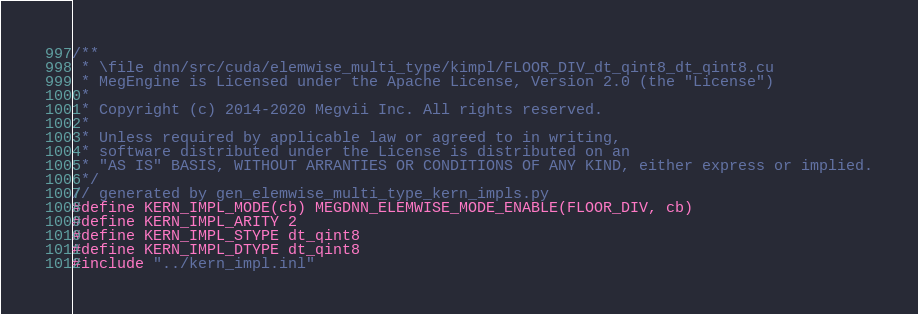Convert code to text. <code><loc_0><loc_0><loc_500><loc_500><_Cuda_>/**
 * \file dnn/src/cuda/elemwise_multi_type/kimpl/FLOOR_DIV_dt_qint8_dt_qint8.cu
 * MegEngine is Licensed under the Apache License, Version 2.0 (the "License")
 *
 * Copyright (c) 2014-2020 Megvii Inc. All rights reserved.
 *
 * Unless required by applicable law or agreed to in writing,
 * software distributed under the License is distributed on an
 * "AS IS" BASIS, WITHOUT ARRANTIES OR CONDITIONS OF ANY KIND, either express or implied.
 */
// generated by gen_elemwise_multi_type_kern_impls.py
#define KERN_IMPL_MODE(cb) MEGDNN_ELEMWISE_MODE_ENABLE(FLOOR_DIV, cb)
#define KERN_IMPL_ARITY 2
#define KERN_IMPL_STYPE dt_qint8
#define KERN_IMPL_DTYPE dt_qint8
#include "../kern_impl.inl"
</code> 